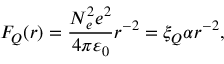<formula> <loc_0><loc_0><loc_500><loc_500>F _ { Q } ( r ) = \frac { N _ { e } ^ { 2 } e ^ { 2 } } { 4 \pi \varepsilon _ { 0 } } r ^ { - 2 } = \xi _ { Q } \alpha r ^ { - 2 } ,</formula> 